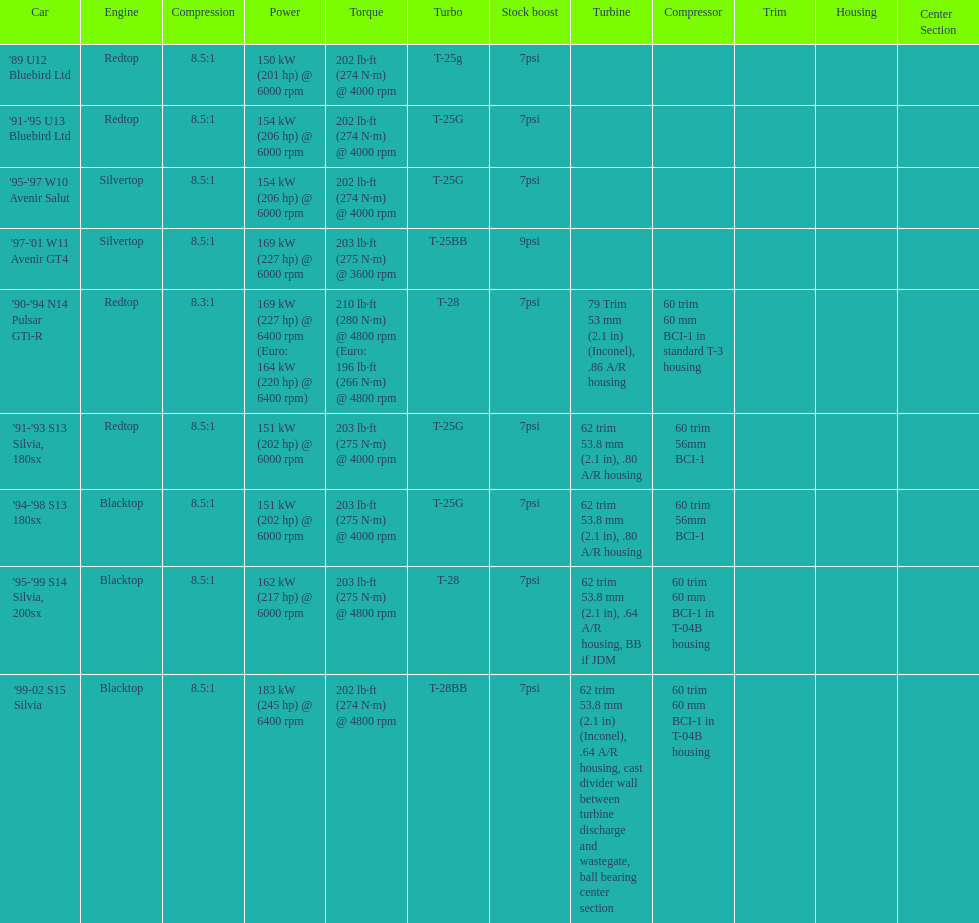Which car's power measured at higher than 6000 rpm? '90-'94 N14 Pulsar GTi-R, '99-02 S15 Silvia. 